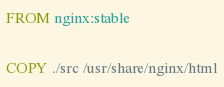Convert code to text. <code><loc_0><loc_0><loc_500><loc_500><_Dockerfile_>FROM nginx:stable

COPY ./src /usr/share/nginx/html
</code> 